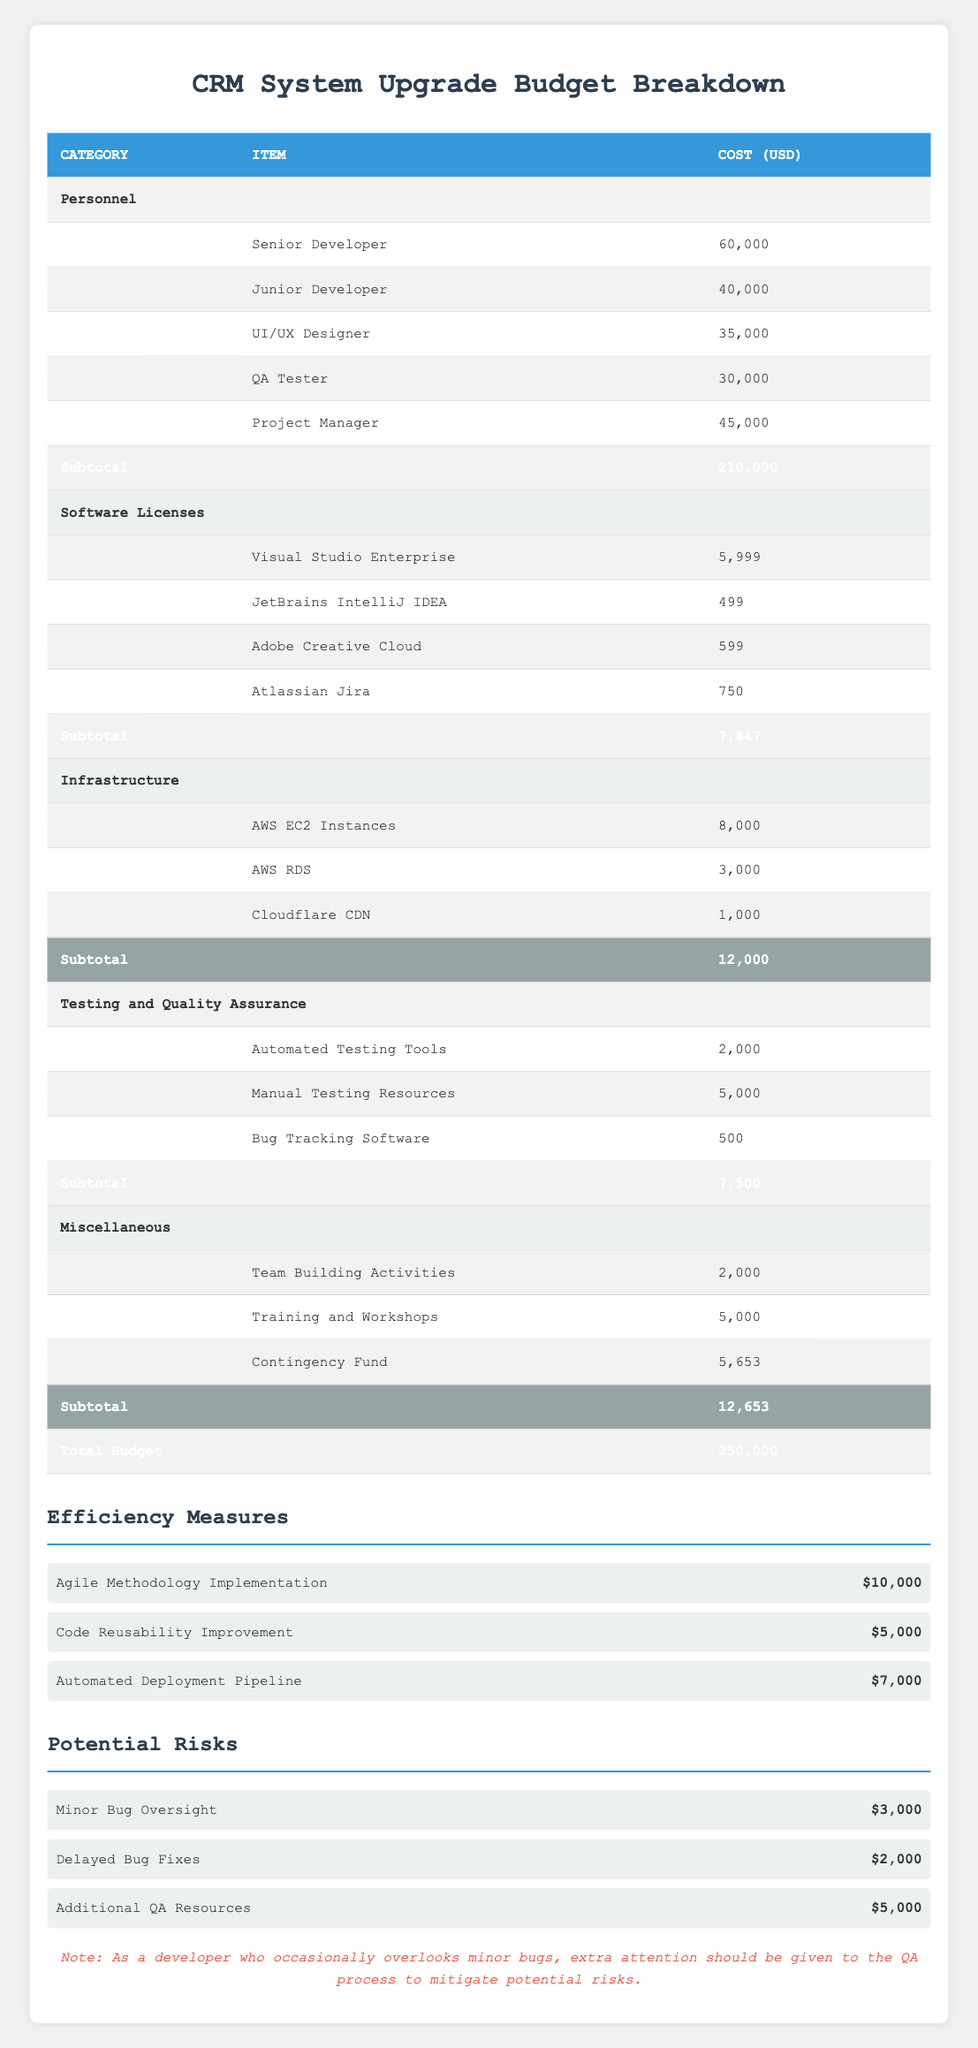What is the total budget for the CRM System Upgrade project? The total budget is explicitly stated in the table under "Total Budget," which shows 250,000 USD.
Answer: 250,000 USD How much does the Project Manager cost? The role of Project Manager is specified in the "Personnel" category with a cost of 45,000 USD.
Answer: 45,000 USD What is the subtotal for the Software Licenses category? The subtotal for Software Licenses is at the bottom of that category, which is 7,847 USD.
Answer: 7,847 USD What is the total cost for Infrastructure items? To find the total cost for Infrastructure, add the individual costs: 8,000 + 3,000 + 1,000 = 12,000 USD.
Answer: 12,000 USD Is the cost of Automated Testing Tools greater than the cost of Manual Testing Resources? Automated Testing Tools cost 2,000 USD, while Manual Testing Resources cost 5,000 USD. Since 2,000 is not greater than 5,000, the answer is no.
Answer: No What are the estimated savings from the Agile Methodology Implementation and the Automated Deployment Pipeline combined? To find the combined savings, add the estimated savings from both measures: 10,000 + 7,000 = 17,000 USD.
Answer: 17,000 USD What is the total amount allocated for Testing and Quality Assurance items? The total for Testing and Quality Assurance can be found by summing the individual costs: 2,000 + 5,000 + 500 = 7,500 USD.
Answer: 7,500 USD Are there any potential risks that have an estimated cost greater than or equal to 5,000 USD? Checking the potential risks, we see "Additional QA Resources" with an estimated cost of 5,000 USD, which meets the criteria. Therefore, the answer is yes.
Answer: Yes How much would the total budget be if we deduct all efficiency measures from the total budget? To find this, first sum the savings from efficiency measures: 10,000 + 5,000 + 7,000 = 22,000 USD. Then subtract this from the total budget: 250,000 - 22,000 = 228,000 USD.
Answer: 228,000 USD What is the cost of the most expensive item in the Personnel category? The most expensive item in the Personnel category is the Senior Developer, costing 60,000 USD.
Answer: 60,000 USD 